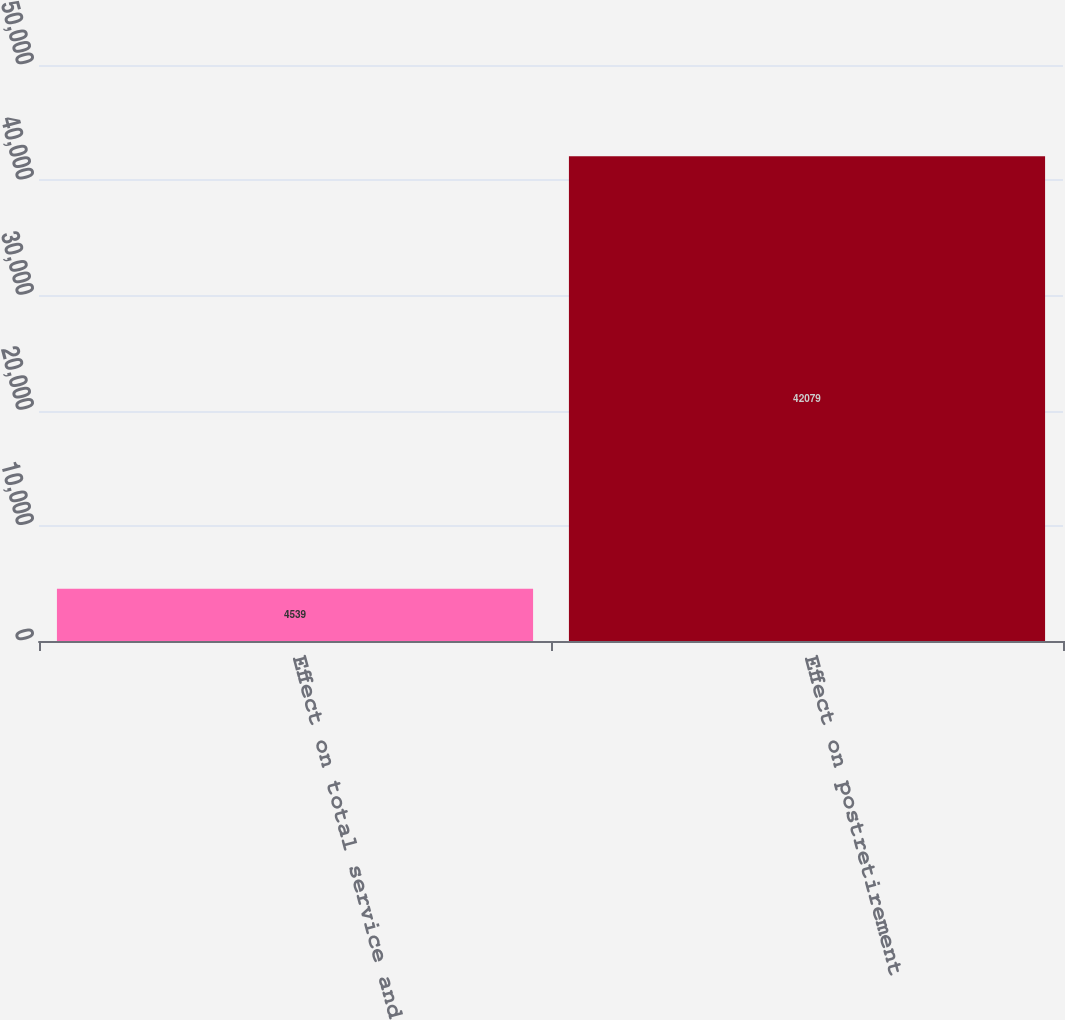Convert chart to OTSL. <chart><loc_0><loc_0><loc_500><loc_500><bar_chart><fcel>Effect on total service and<fcel>Effect on postretirement<nl><fcel>4539<fcel>42079<nl></chart> 